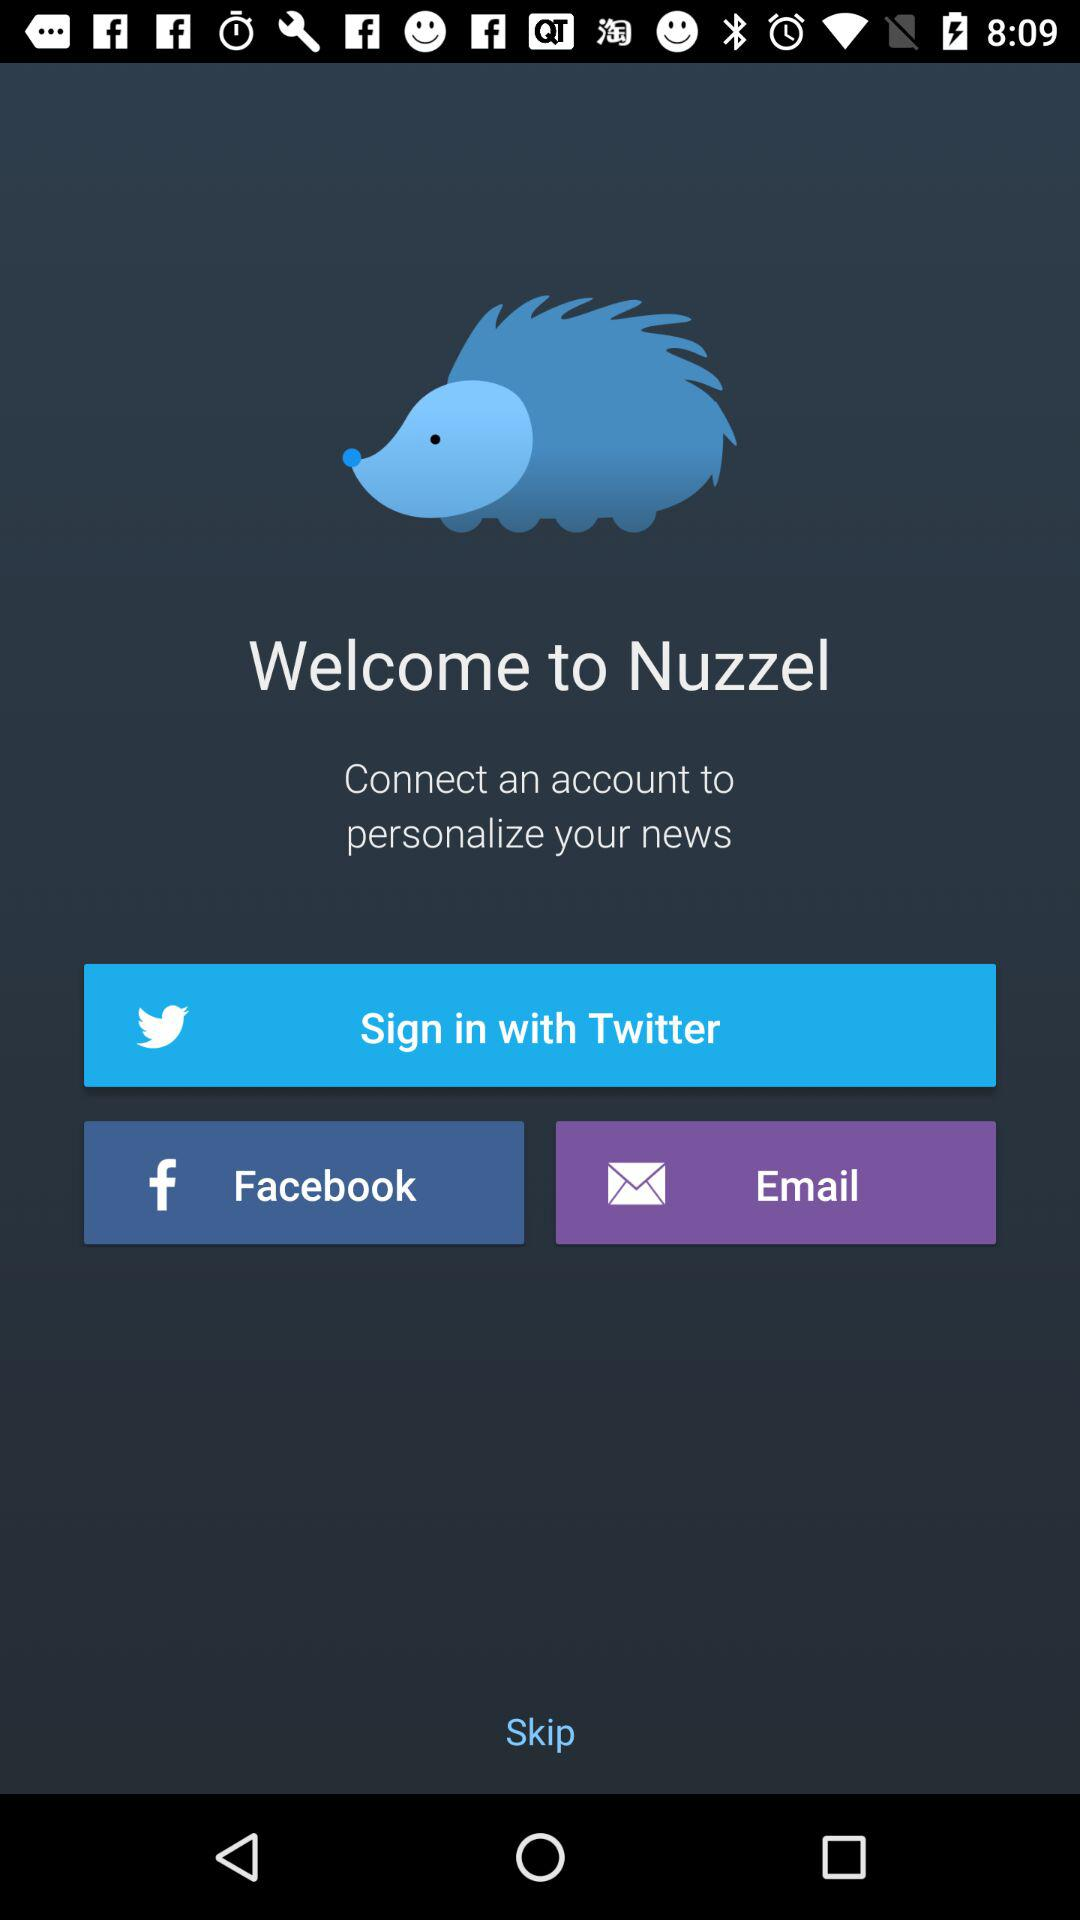What are the options for signing in? The options for signing in are "Twitter", "Facebook" and "Email". 